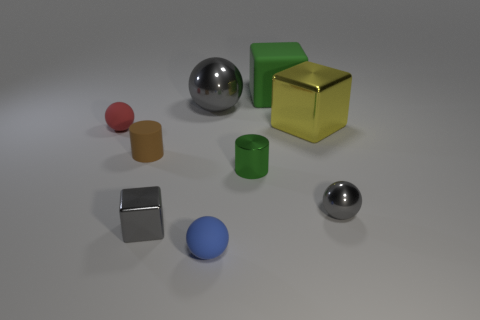Subtract all yellow cylinders. Subtract all green balls. How many cylinders are left? 2 Add 1 green shiny blocks. How many objects exist? 10 Subtract all cubes. How many objects are left? 6 Subtract all small yellow objects. Subtract all green cubes. How many objects are left? 8 Add 1 tiny cubes. How many tiny cubes are left? 2 Add 6 small blue balls. How many small blue balls exist? 7 Subtract 0 red cylinders. How many objects are left? 9 